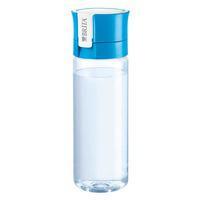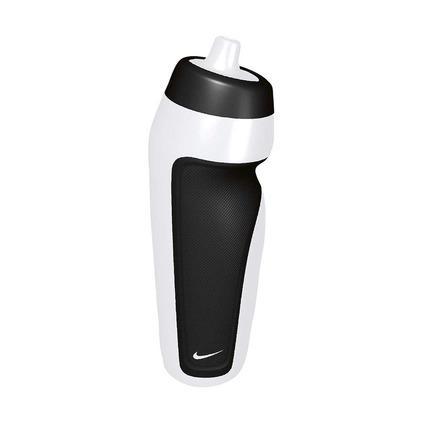The first image is the image on the left, the second image is the image on the right. Given the left and right images, does the statement "Both of the containers are made of a clear tinted material." hold true? Answer yes or no. No. The first image is the image on the left, the second image is the image on the right. Considering the images on both sides, is "An image shows one water bottle with a black section and an indented shape." valid? Answer yes or no. Yes. 